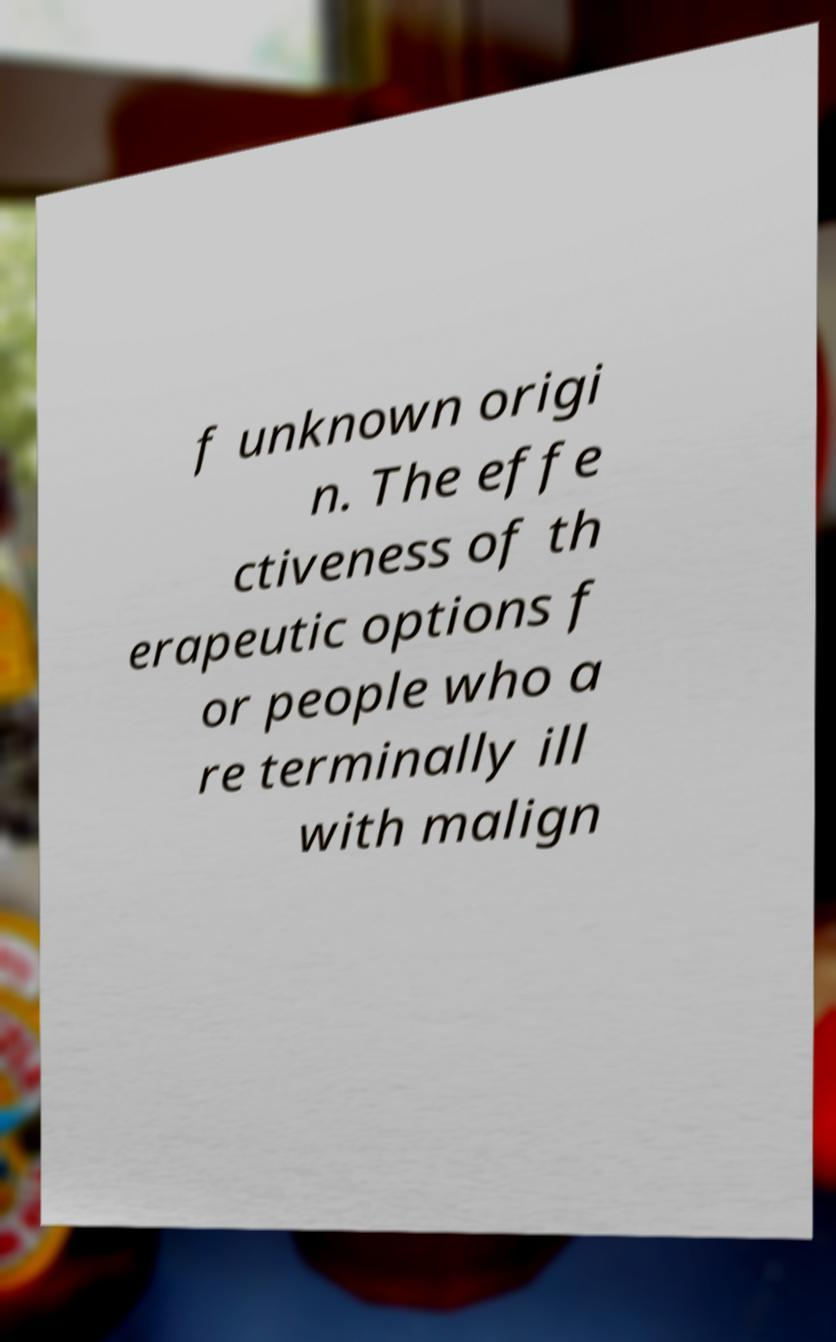What messages or text are displayed in this image? I need them in a readable, typed format. f unknown origi n. The effe ctiveness of th erapeutic options f or people who a re terminally ill with malign 